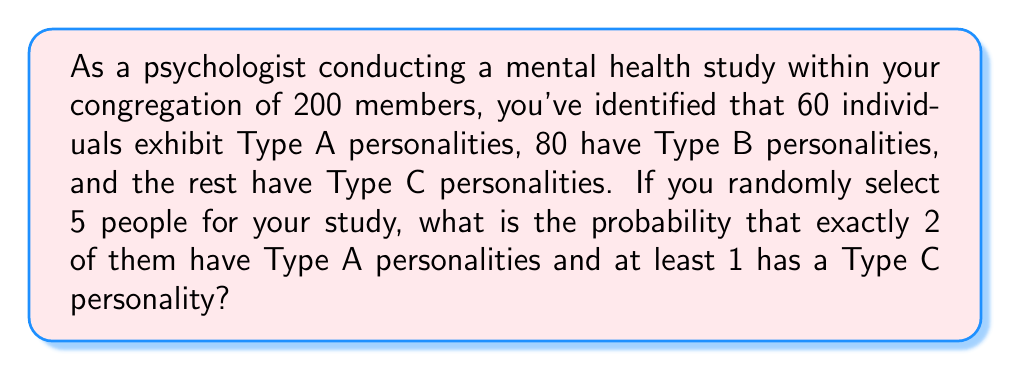Show me your answer to this math problem. Let's approach this step-by-step:

1) First, let's identify the number of people with each personality type:
   Type A: 60
   Type B: 80
   Type C: 200 - 60 - 80 = 60

2) We need to calculate the probability of selecting exactly 2 Type A and at least 1 Type C out of 5 people. This can happen in two ways:
   a) 2 Type A, 1 Type C, 2 Type B
   b) 2 Type A, 2 Type C, 1 Type B or 2 Type A, 3 Type C, 0 Type B

3) Let's calculate the probability for each scenario:

   a) P(2A, 1C, 2B) = $\frac{\binom{60}{2} \cdot \binom{60}{1} \cdot \binom{80}{2}}{\binom{200}{5}}$

   b) P(2A, 2C, 1B) + P(2A, 3C, 0B) = $\frac{\binom{60}{2} \cdot \binom{60}{2} \cdot \binom{80}{1}}{\binom{200}{5}} + \frac{\binom{60}{2} \cdot \binom{60}{3}}{\binom{200}{5}}$

4) Let's calculate each part:

   $\binom{60}{2} = 1770$
   $\binom{60}{1} = 60$
   $\binom{80}{2} = 3160$
   $\binom{80}{1} = 80$
   $\binom{60}{3} = 34220$
   $\binom{200}{5} = 2,535,650,040$

5) Now, let's substitute these values:

   P(2A, 1C, 2B) = $\frac{1770 \cdot 60 \cdot 3160}{2,535,650,040} = 0.0132$

   P(2A, 2C, 1B) + P(2A, 3C, 0B) = $\frac{1770 \cdot 1770 \cdot 80}{2,535,650,040} + \frac{1770 \cdot 34220}{2,535,650,040} = 0.0098 + 0.0238 = 0.0336$

6) The total probability is the sum of these:

   0.0132 + 0.0336 = 0.0468
Answer: The probability is approximately 0.0468 or 4.68%. 